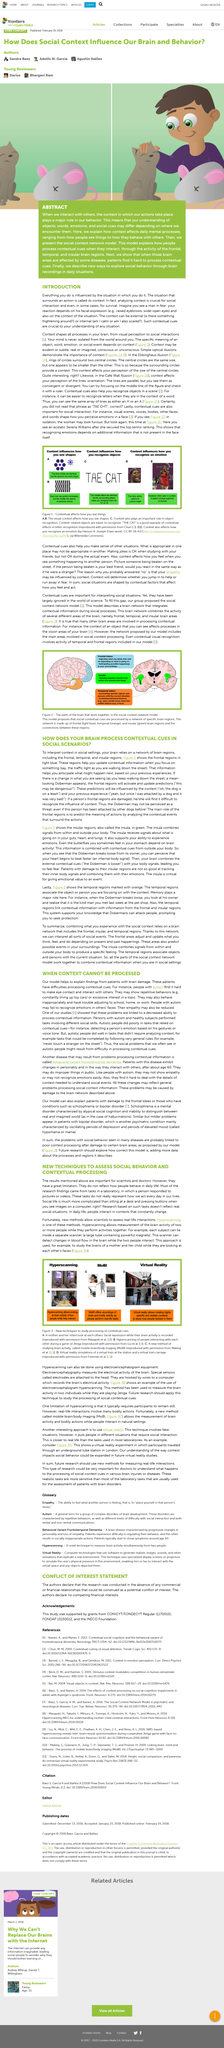Indicate a few pertinent items in this graphic. Everything influences the situation in which I do it. Some facial expressions that convey fear include raised eyebrows and wide-open eyes. In daily life, people's interactions differ greatly from those observed in a laboratory setting, as they take place in a variety of constantly changing contexts. The study of social behavior and contextual processing is typically conducted in laboratories where individuals are seated in front of computers. The article promises to demonstrate innovative methods for investigating a specific topic. 